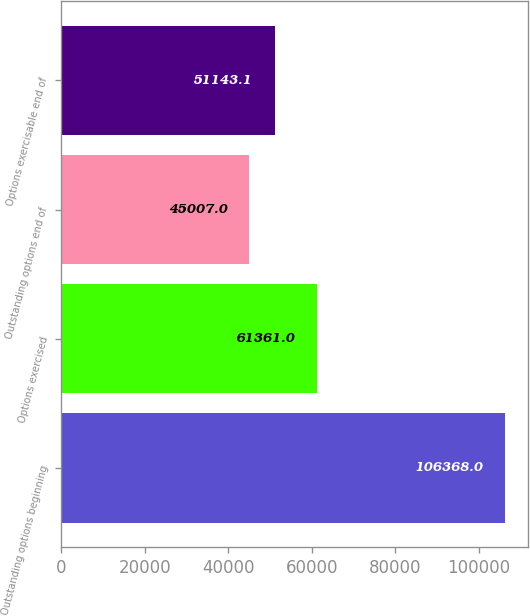<chart> <loc_0><loc_0><loc_500><loc_500><bar_chart><fcel>Outstanding options beginning<fcel>Options exercised<fcel>Outstanding options end of<fcel>Options exercisable end of<nl><fcel>106368<fcel>61361<fcel>45007<fcel>51143.1<nl></chart> 